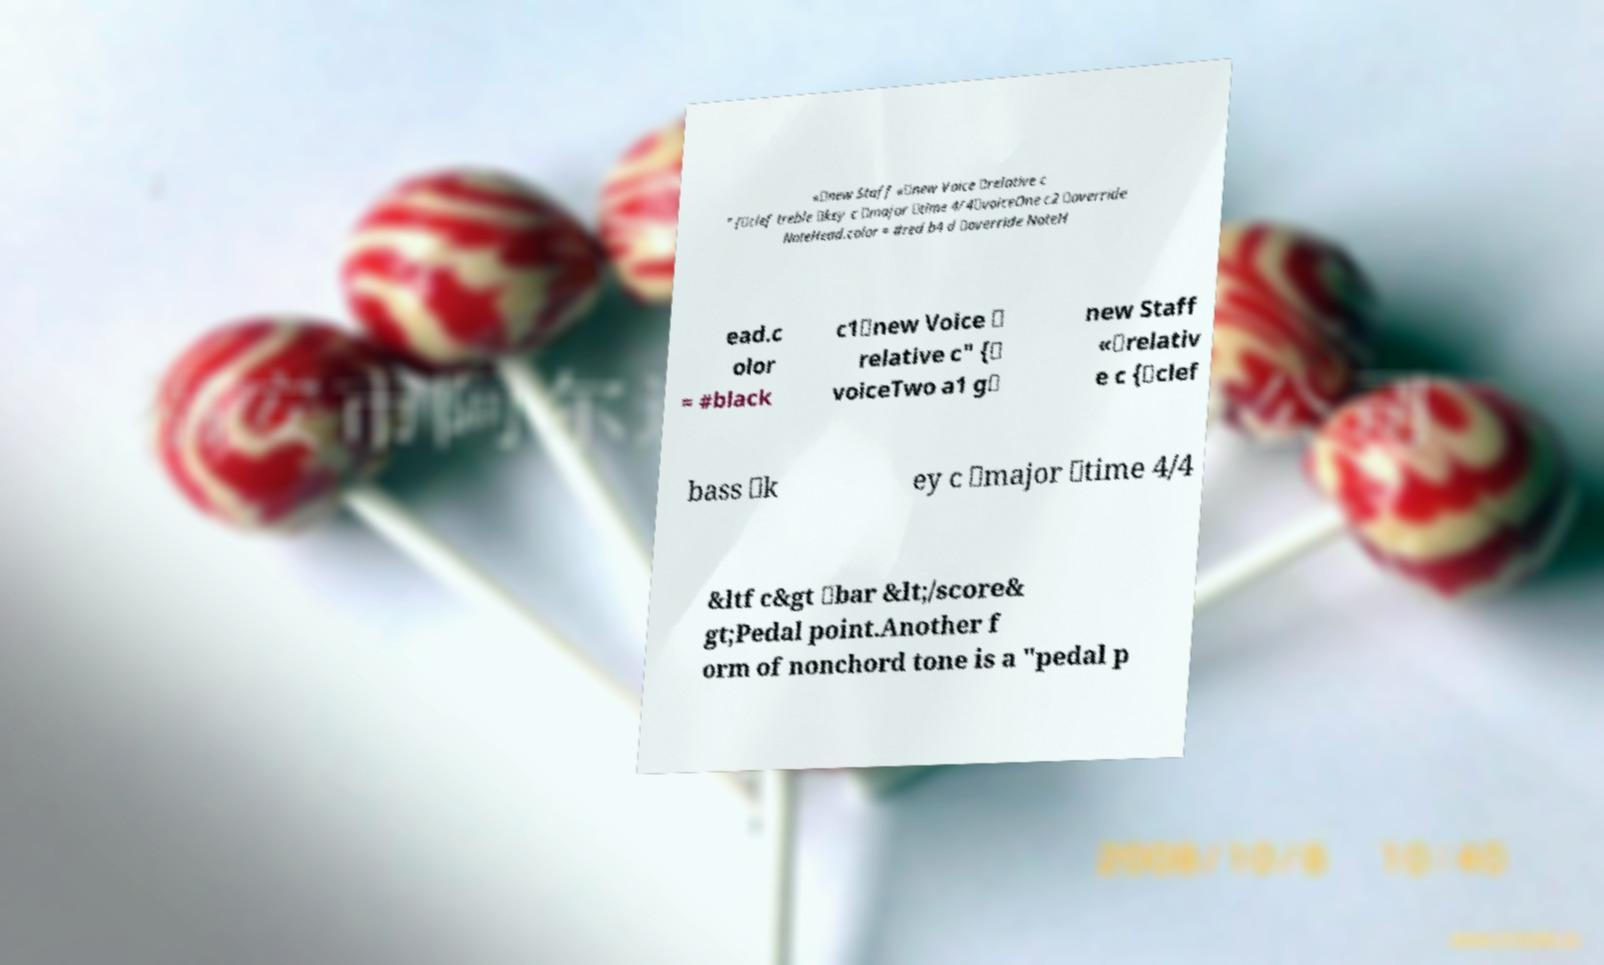For documentation purposes, I need the text within this image transcribed. Could you provide that? «\new Staff «\new Voice \relative c " {\clef treble \key c \major \time 4/4\voiceOne c2 \override NoteHead.color = #red b4 d \override NoteH ead.c olor = #black c1\new Voice \ relative c" {\ voiceTwo a1 g\ new Staff «\relativ e c {\clef bass \k ey c \major \time 4/4 &ltf c&gt \bar &lt;/score& gt;Pedal point.Another f orm of nonchord tone is a "pedal p 